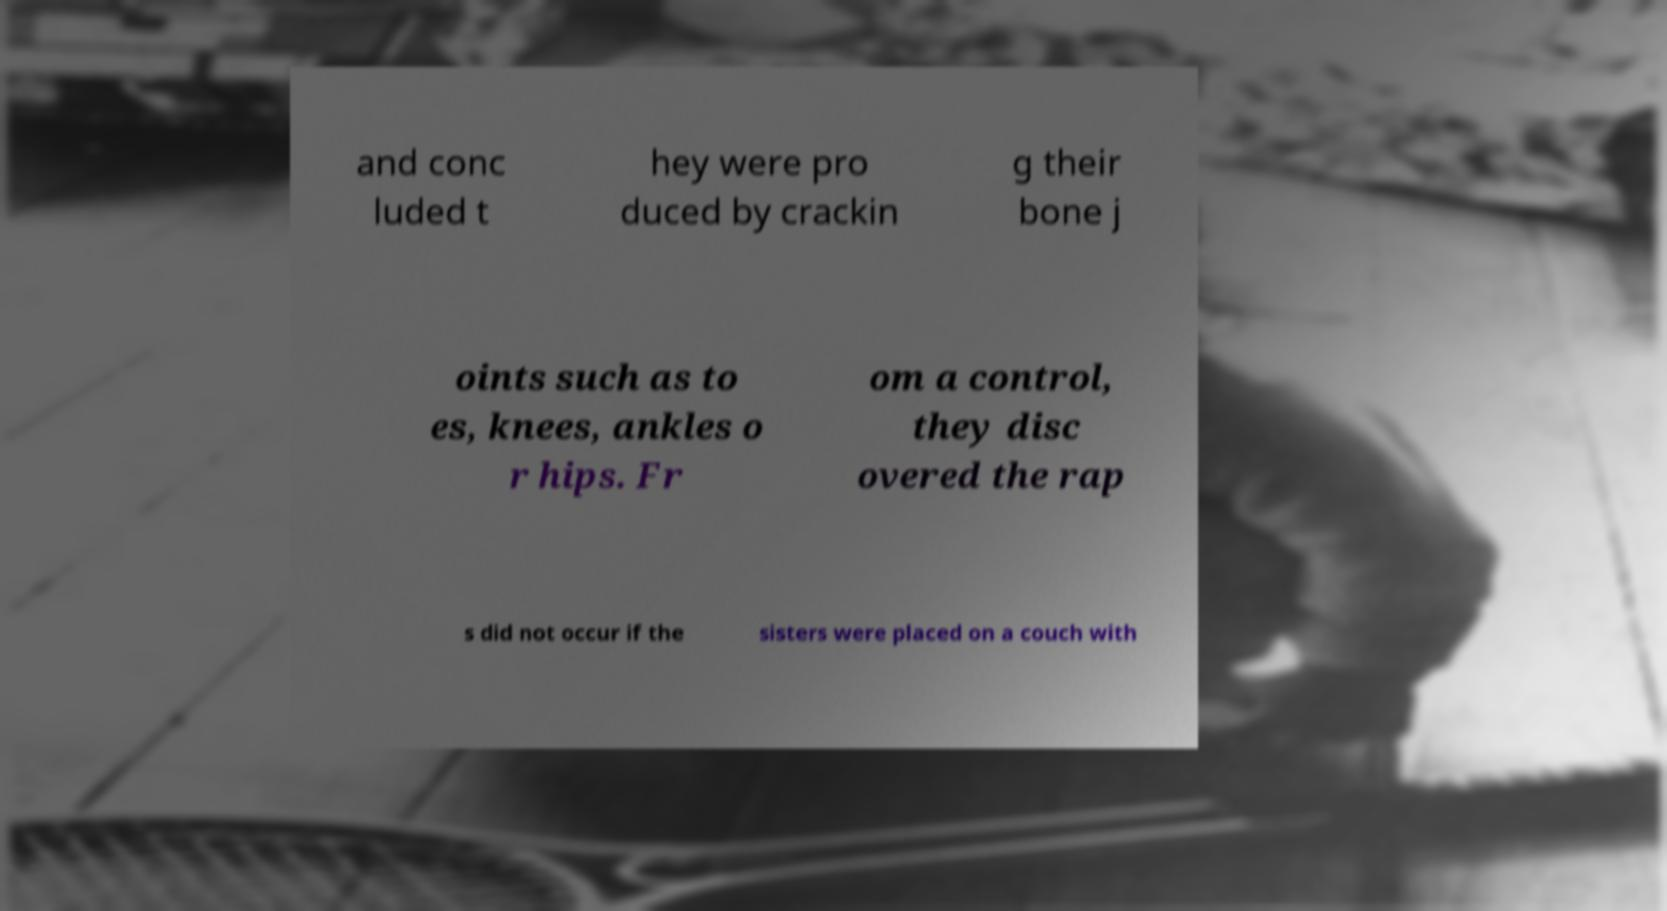Please read and relay the text visible in this image. What does it say? and conc luded t hey were pro duced by crackin g their bone j oints such as to es, knees, ankles o r hips. Fr om a control, they disc overed the rap s did not occur if the sisters were placed on a couch with 